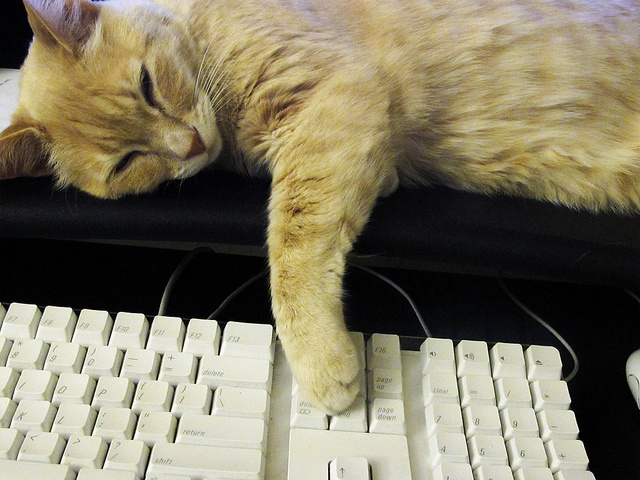Describe the objects in this image and their specific colors. I can see cat in black, tan, and olive tones and keyboard in black, beige, darkgray, and olive tones in this image. 